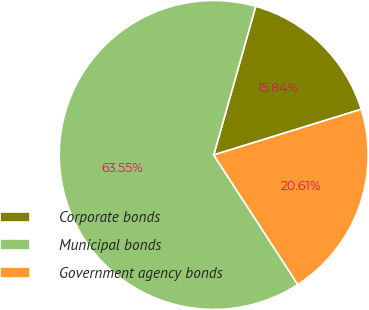<chart> <loc_0><loc_0><loc_500><loc_500><pie_chart><fcel>Corporate bonds<fcel>Municipal bonds<fcel>Government agency bonds<nl><fcel>15.84%<fcel>63.54%<fcel>20.61%<nl></chart> 